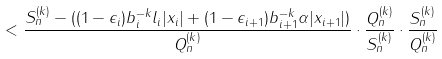<formula> <loc_0><loc_0><loc_500><loc_500>< \frac { S _ { n } ^ { ( k ) } - ( ( 1 - \epsilon _ { i } ) b _ { i } ^ { - k } l _ { i } | x _ { i } | + ( 1 - \epsilon _ { i + 1 } ) b _ { i + 1 } ^ { - k } \alpha | x _ { i + 1 } | ) } { Q _ { n } ^ { ( k ) } } \cdot \frac { Q _ { n } ^ { ( k ) } } { S _ { n } ^ { ( k ) } } \cdot \frac { S _ { n } ^ { ( k ) } } { Q _ { n } ^ { ( k ) } }</formula> 